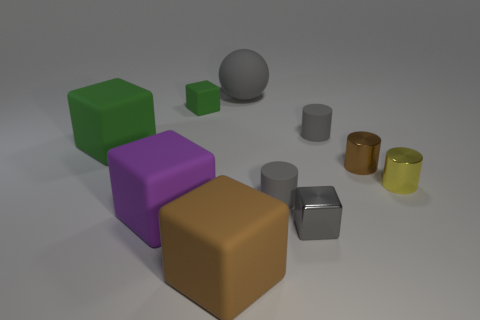Subtract all brown cubes. How many cubes are left? 4 Subtract all metallic cubes. How many cubes are left? 4 Subtract all blue blocks. Subtract all cyan balls. How many blocks are left? 5 Subtract all balls. How many objects are left? 9 Add 5 purple matte objects. How many purple matte objects are left? 6 Add 1 purple metal cylinders. How many purple metal cylinders exist? 1 Subtract 0 red blocks. How many objects are left? 10 Subtract all small metal blocks. Subtract all big brown blocks. How many objects are left? 8 